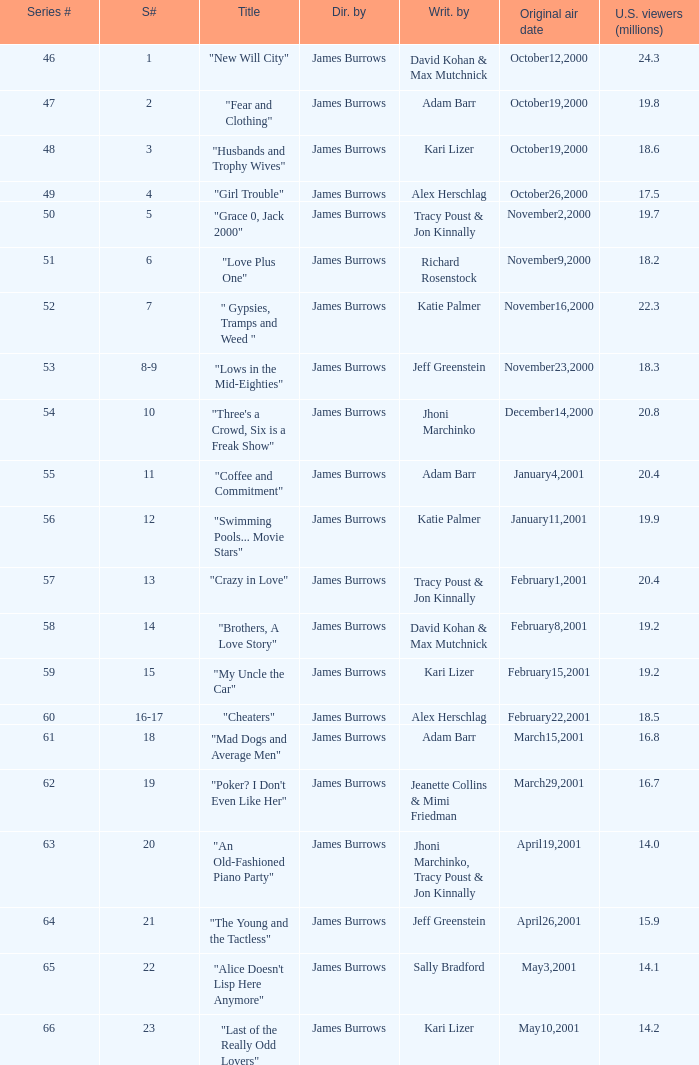Give me the full table as a dictionary. {'header': ['Series #', 'S#', 'Title', 'Dir. by', 'Writ. by', 'Original air date', 'U.S. viewers (millions)'], 'rows': [['46', '1', '"New Will City"', 'James Burrows', 'David Kohan & Max Mutchnick', 'October12,2000', '24.3'], ['47', '2', '"Fear and Clothing"', 'James Burrows', 'Adam Barr', 'October19,2000', '19.8'], ['48', '3', '"Husbands and Trophy Wives"', 'James Burrows', 'Kari Lizer', 'October19,2000', '18.6'], ['49', '4', '"Girl Trouble"', 'James Burrows', 'Alex Herschlag', 'October26,2000', '17.5'], ['50', '5', '"Grace 0, Jack 2000"', 'James Burrows', 'Tracy Poust & Jon Kinnally', 'November2,2000', '19.7'], ['51', '6', '"Love Plus One"', 'James Burrows', 'Richard Rosenstock', 'November9,2000', '18.2'], ['52', '7', '" Gypsies, Tramps and Weed "', 'James Burrows', 'Katie Palmer', 'November16,2000', '22.3'], ['53', '8-9', '"Lows in the Mid-Eighties"', 'James Burrows', 'Jeff Greenstein', 'November23,2000', '18.3'], ['54', '10', '"Three\'s a Crowd, Six is a Freak Show"', 'James Burrows', 'Jhoni Marchinko', 'December14,2000', '20.8'], ['55', '11', '"Coffee and Commitment"', 'James Burrows', 'Adam Barr', 'January4,2001', '20.4'], ['56', '12', '"Swimming Pools... Movie Stars"', 'James Burrows', 'Katie Palmer', 'January11,2001', '19.9'], ['57', '13', '"Crazy in Love"', 'James Burrows', 'Tracy Poust & Jon Kinnally', 'February1,2001', '20.4'], ['58', '14', '"Brothers, A Love Story"', 'James Burrows', 'David Kohan & Max Mutchnick', 'February8,2001', '19.2'], ['59', '15', '"My Uncle the Car"', 'James Burrows', 'Kari Lizer', 'February15,2001', '19.2'], ['60', '16-17', '"Cheaters"', 'James Burrows', 'Alex Herschlag', 'February22,2001', '18.5'], ['61', '18', '"Mad Dogs and Average Men"', 'James Burrows', 'Adam Barr', 'March15,2001', '16.8'], ['62', '19', '"Poker? I Don\'t Even Like Her"', 'James Burrows', 'Jeanette Collins & Mimi Friedman', 'March29,2001', '16.7'], ['63', '20', '"An Old-Fashioned Piano Party"', 'James Burrows', 'Jhoni Marchinko, Tracy Poust & Jon Kinnally', 'April19,2001', '14.0'], ['64', '21', '"The Young and the Tactless"', 'James Burrows', 'Jeff Greenstein', 'April26,2001', '15.9'], ['65', '22', '"Alice Doesn\'t Lisp Here Anymore"', 'James Burrows', 'Sally Bradford', 'May3,2001', '14.1'], ['66', '23', '"Last of the Really Odd Lovers"', 'James Burrows', 'Kari Lizer', 'May10,2001', '14.2']]} Who wrote the episode titled "An Old-fashioned Piano Party"? Jhoni Marchinko, Tracy Poust & Jon Kinnally. 